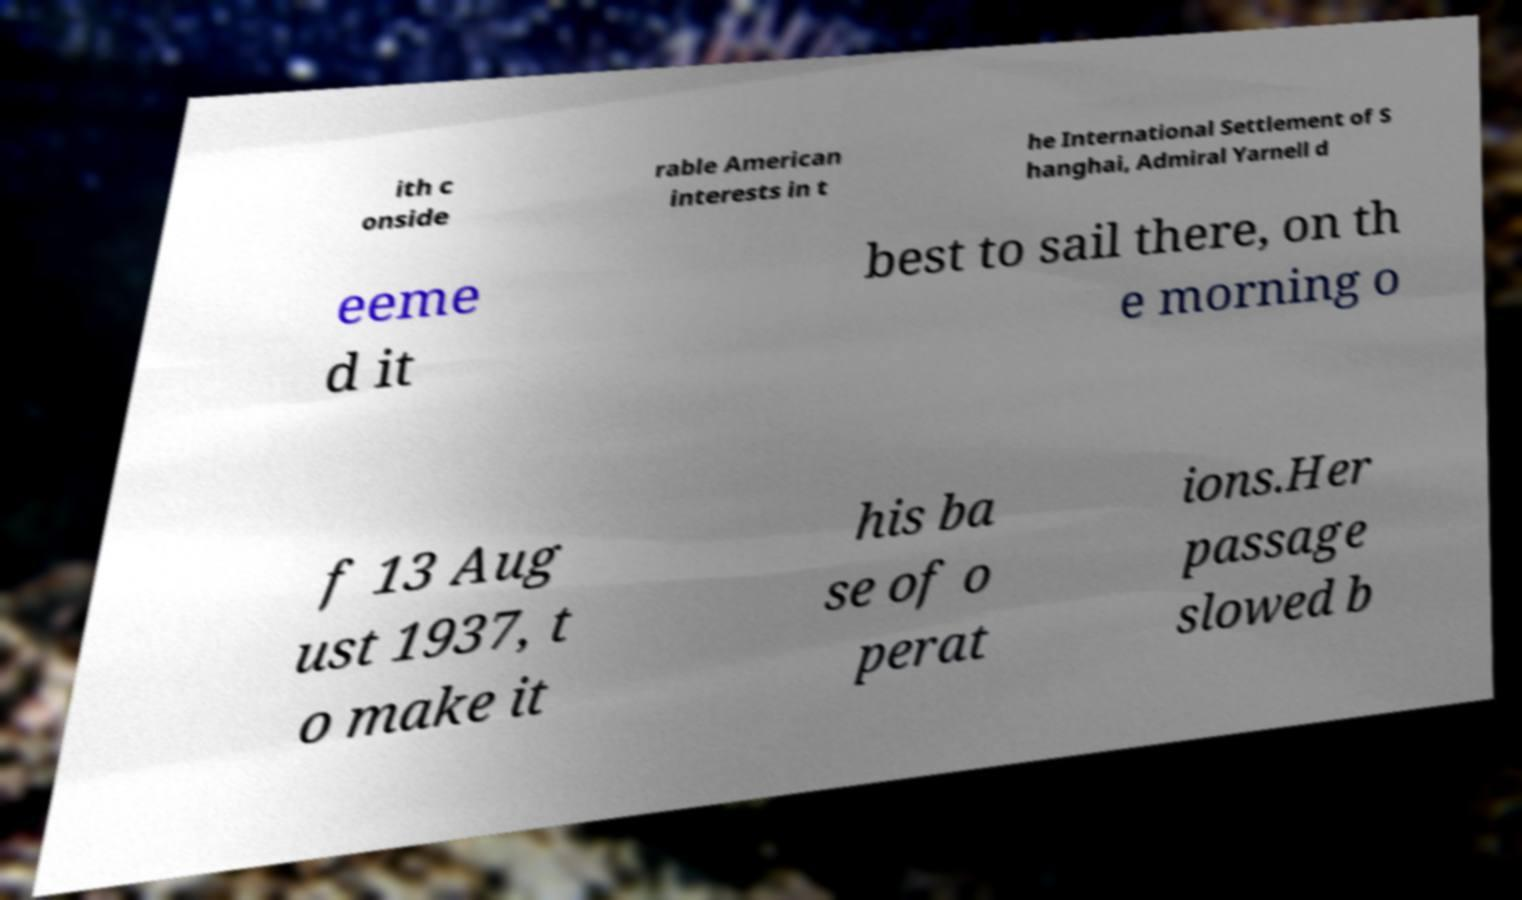What messages or text are displayed in this image? I need them in a readable, typed format. ith c onside rable American interests in t he International Settlement of S hanghai, Admiral Yarnell d eeme d it best to sail there, on th e morning o f 13 Aug ust 1937, t o make it his ba se of o perat ions.Her passage slowed b 